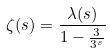Convert formula to latex. <formula><loc_0><loc_0><loc_500><loc_500>\zeta ( s ) = \frac { \lambda ( s ) } { 1 - \frac { 3 } { 3 ^ { s } } }</formula> 